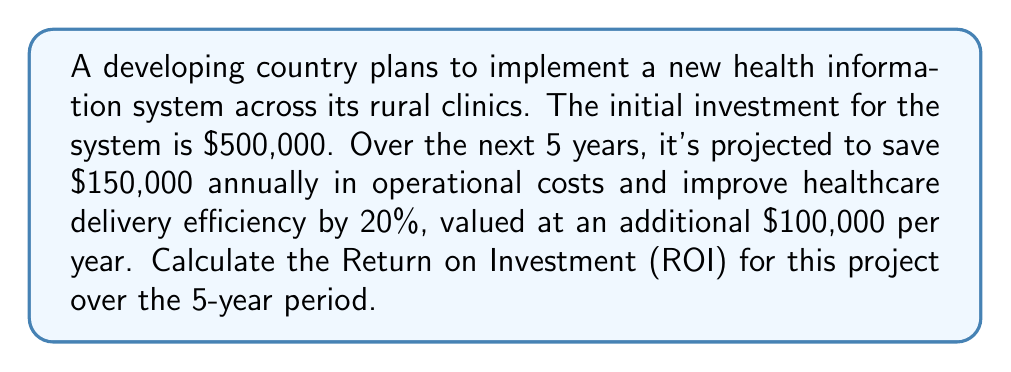Give your solution to this math problem. To calculate the Return on Investment (ROI), we need to follow these steps:

1. Calculate the total benefits over the 5-year period:
   Annual benefit = Cost savings + Value of efficiency improvement
   $$\text{Annual benefit} = \$150,000 + \$100,000 = \$250,000$$
   Total benefit over 5 years = Annual benefit × 5 years
   $$\text{Total benefit} = \$250,000 \times 5 = \$1,250,000$$

2. Calculate the net profit:
   Net profit = Total benefit - Initial investment
   $$\text{Net profit} = \$1,250,000 - \$500,000 = \$750,000$$

3. Calculate the ROI using the formula:
   $$\text{ROI} = \frac{\text{Net Profit}}{\text{Initial Investment}} \times 100\%$$

   Substituting our values:
   $$\text{ROI} = \frac{\$750,000}{\$500,000} \times 100\% = 1.5 \times 100\% = 150\%$$

Therefore, the ROI for implementing the new health information system over the 5-year period is 150%.
Answer: The Return on Investment (ROI) for implementing the new health information system in the developing country over the 5-year period is 150%. 